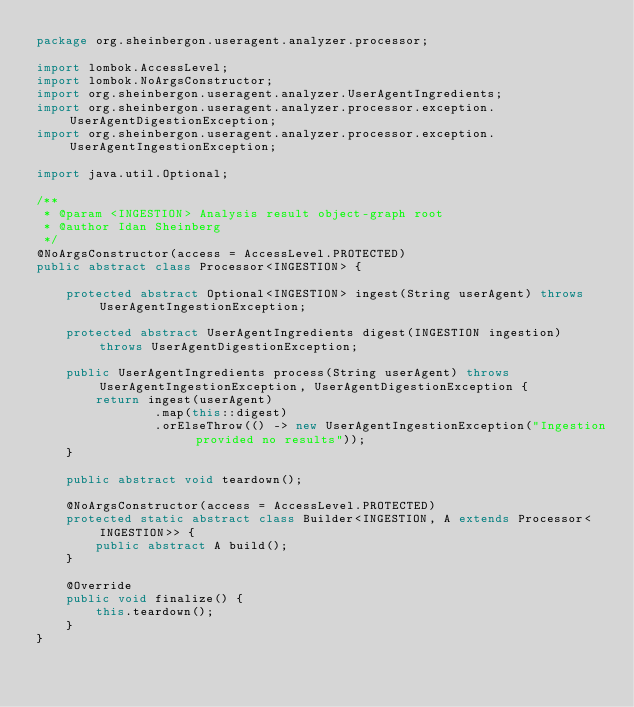<code> <loc_0><loc_0><loc_500><loc_500><_Java_>package org.sheinbergon.useragent.analyzer.processor;

import lombok.AccessLevel;
import lombok.NoArgsConstructor;
import org.sheinbergon.useragent.analyzer.UserAgentIngredients;
import org.sheinbergon.useragent.analyzer.processor.exception.UserAgentDigestionException;
import org.sheinbergon.useragent.analyzer.processor.exception.UserAgentIngestionException;

import java.util.Optional;

/**
 * @param <INGESTION> Analysis result object-graph root
 * @author Idan Sheinberg
 */
@NoArgsConstructor(access = AccessLevel.PROTECTED)
public abstract class Processor<INGESTION> {

    protected abstract Optional<INGESTION> ingest(String userAgent) throws UserAgentIngestionException;

    protected abstract UserAgentIngredients digest(INGESTION ingestion) throws UserAgentDigestionException;

    public UserAgentIngredients process(String userAgent) throws UserAgentIngestionException, UserAgentDigestionException {
        return ingest(userAgent)
                .map(this::digest)
                .orElseThrow(() -> new UserAgentIngestionException("Ingestion provided no results"));
    }

    public abstract void teardown();

    @NoArgsConstructor(access = AccessLevel.PROTECTED)
    protected static abstract class Builder<INGESTION, A extends Processor<INGESTION>> {
        public abstract A build();
    }

    @Override
    public void finalize() {
        this.teardown();
    }
}
</code> 